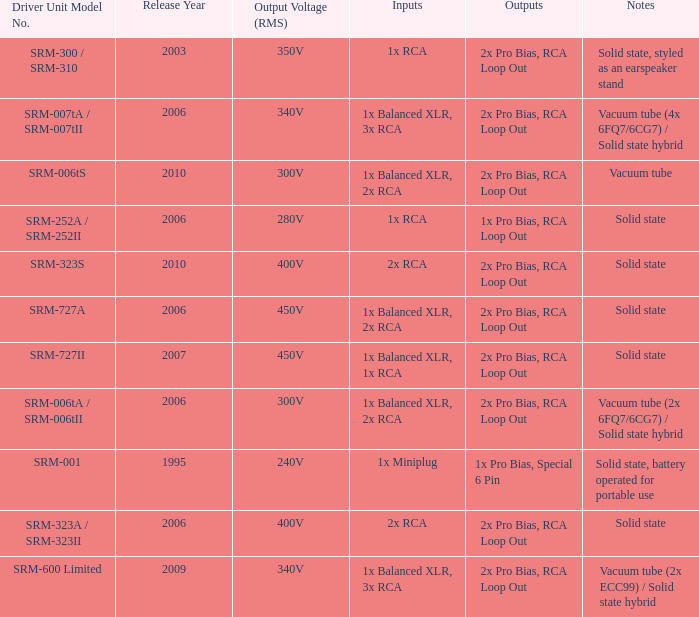How many outputs are there for solid state, battery operated for portable use listed in notes? 1.0. 